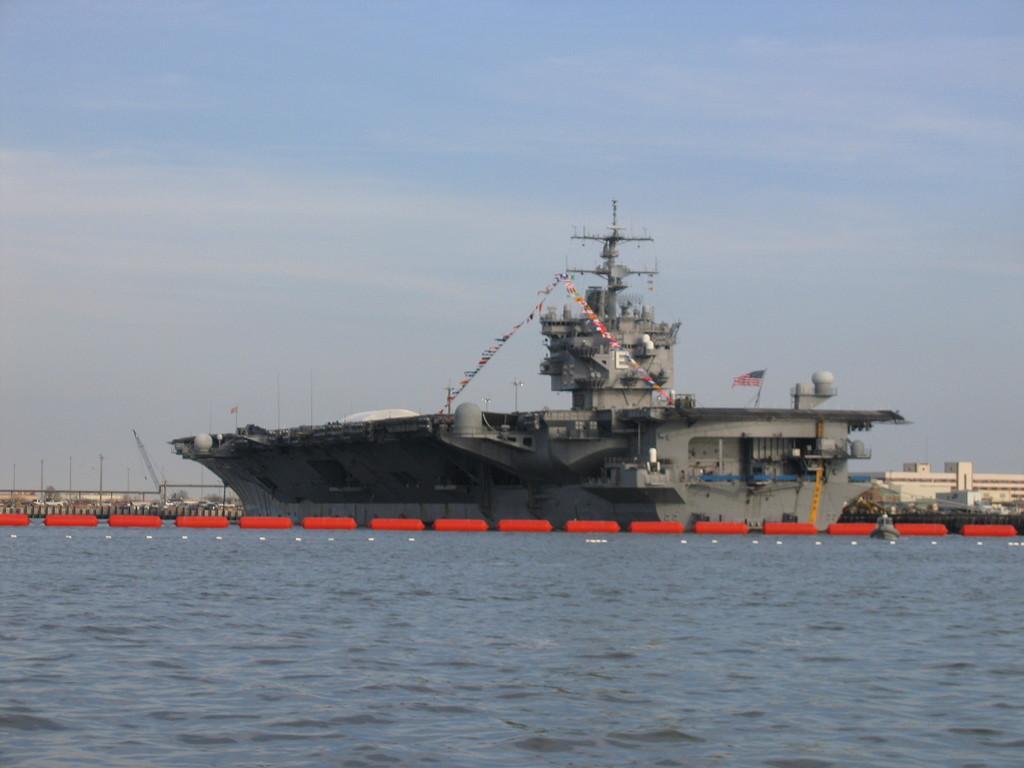Can you describe this image briefly? There is water. Also there is a ship in the water. Near to that there is a red color rope like thing in the water. In the back there is building and sky. On the ship there is a flag. 